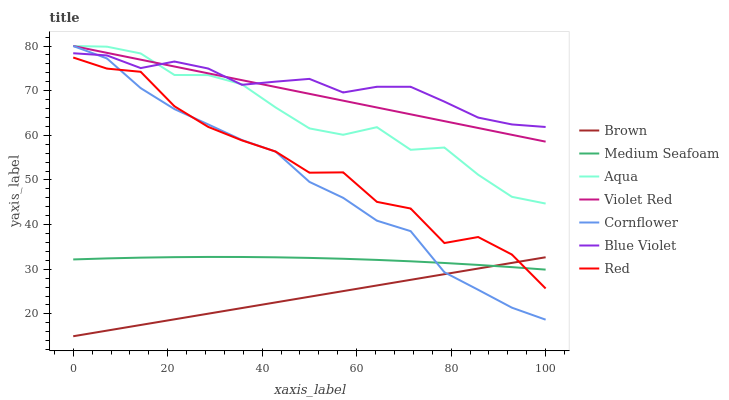Does Brown have the minimum area under the curve?
Answer yes or no. Yes. Does Blue Violet have the maximum area under the curve?
Answer yes or no. Yes. Does Violet Red have the minimum area under the curve?
Answer yes or no. No. Does Violet Red have the maximum area under the curve?
Answer yes or no. No. Is Violet Red the smoothest?
Answer yes or no. Yes. Is Red the roughest?
Answer yes or no. Yes. Is Cornflower the smoothest?
Answer yes or no. No. Is Cornflower the roughest?
Answer yes or no. No. Does Brown have the lowest value?
Answer yes or no. Yes. Does Violet Red have the lowest value?
Answer yes or no. No. Does Aqua have the highest value?
Answer yes or no. Yes. Does Red have the highest value?
Answer yes or no. No. Is Medium Seafoam less than Aqua?
Answer yes or no. Yes. Is Aqua greater than Medium Seafoam?
Answer yes or no. Yes. Does Aqua intersect Violet Red?
Answer yes or no. Yes. Is Aqua less than Violet Red?
Answer yes or no. No. Is Aqua greater than Violet Red?
Answer yes or no. No. Does Medium Seafoam intersect Aqua?
Answer yes or no. No. 